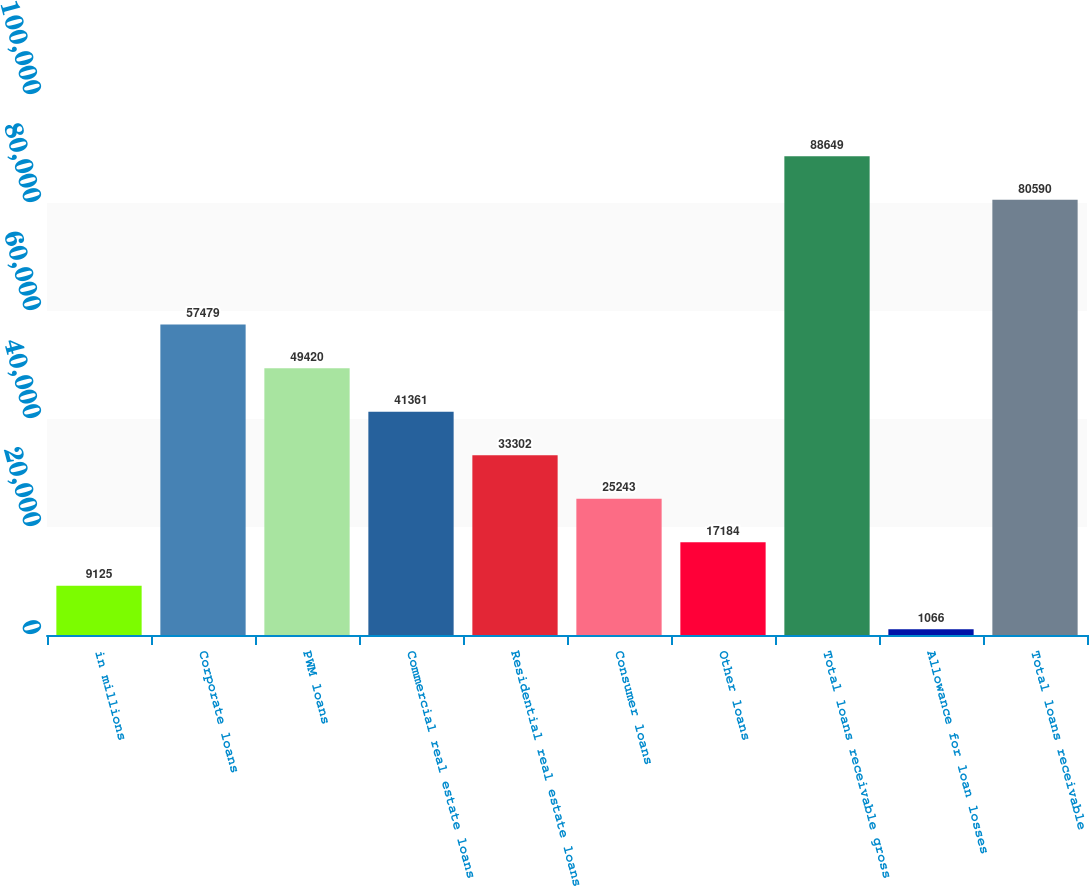Convert chart. <chart><loc_0><loc_0><loc_500><loc_500><bar_chart><fcel>in millions<fcel>Corporate loans<fcel>PWM loans<fcel>Commercial real estate loans<fcel>Residential real estate loans<fcel>Consumer loans<fcel>Other loans<fcel>Total loans receivable gross<fcel>Allowance for loan losses<fcel>Total loans receivable<nl><fcel>9125<fcel>57479<fcel>49420<fcel>41361<fcel>33302<fcel>25243<fcel>17184<fcel>88649<fcel>1066<fcel>80590<nl></chart> 